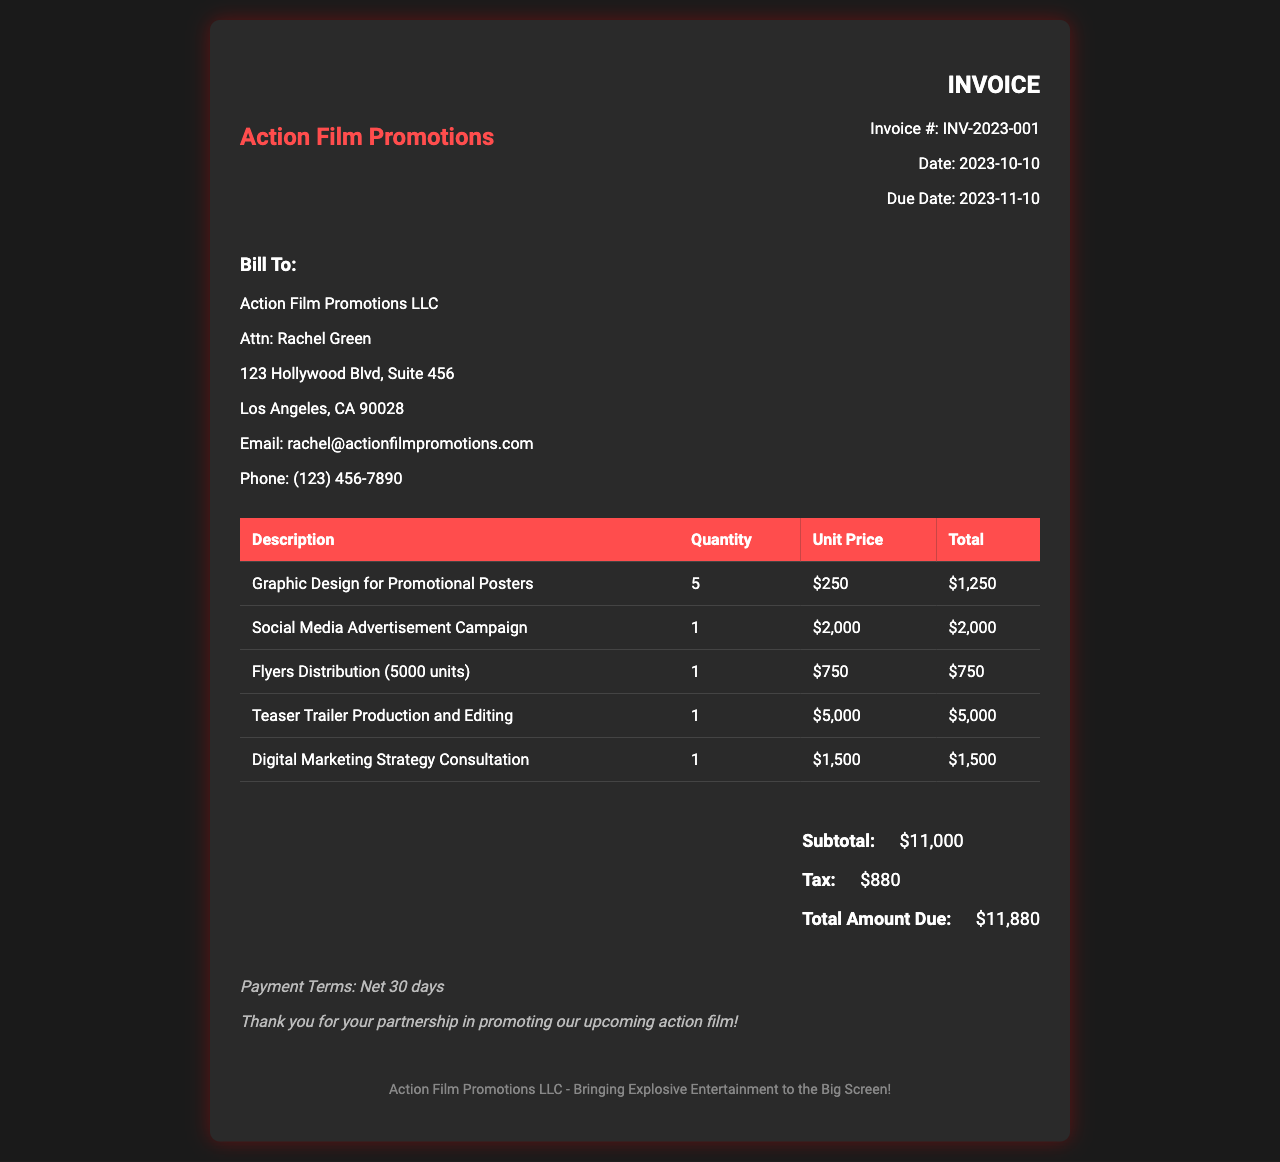What is the invoice number? The invoice number is listed specifically at the top of the document.
Answer: INV-2023-001 Who is the client? The client information is detailed in the client section of the invoice.
Answer: Action Film Promotions LLC What is the due date for the invoice? The due date is clearly stated in the invoice details section.
Answer: 2023-11-10 How much is the subtotal? The subtotal can be found in the total section of the invoice.
Answer: $11,000 What service has the highest cost? The service costs are listed in a table, requiring comparison to identify the highest one.
Answer: Teaser Trailer Production and Editing How many flyers were distributed? The quantity of flyers is specified under the corresponding service description.
Answer: 5000 units What is the total amount due? The total amount due is calculated and listed in the total section of the invoice.
Answer: $11,880 What are the payment terms? The payment terms are provided near the bottom of the invoice in the notes section.
Answer: Net 30 days What is the purpose of this invoice? The document's purpose can be inferred from the services it lists and its overall theme.
Answer: Promotional materials and advertising costs 